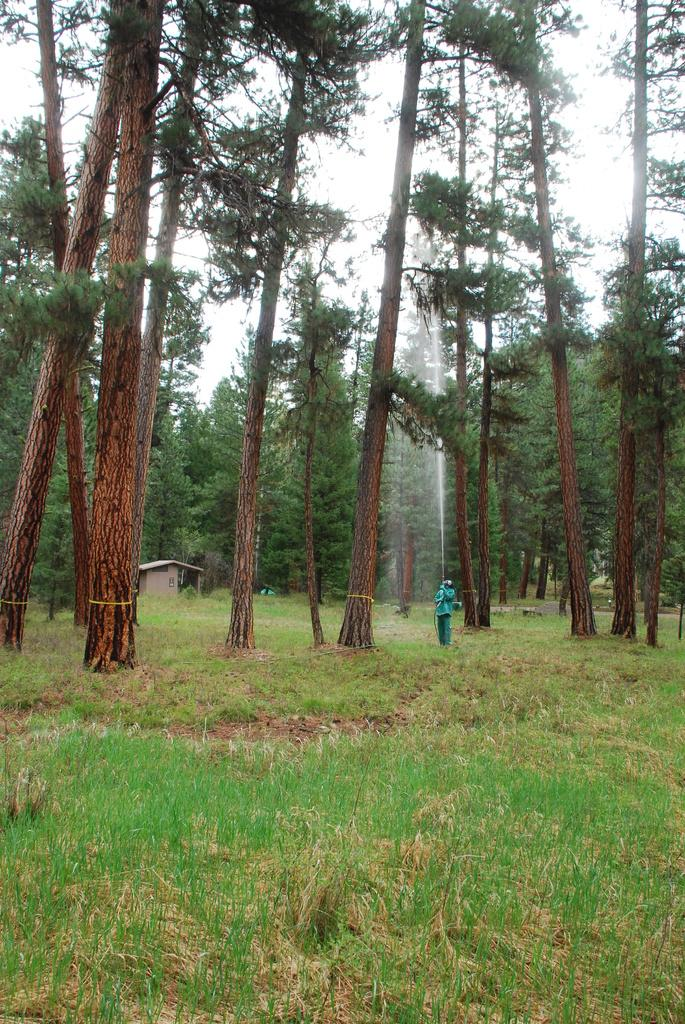What type of vegetation is present at the bottom of the image? There is grass on the ground at the bottom of the image. What can be seen in the distance in the image? There are trees, a person watering something, a house, and other objects in the background of the image. What is visible in the sky in the image? The sky is visible in the background of the image. What type of soup is being served in the image? There is no soup present in the image. Is the person in the image taking a bath? There is no indication of a bath or any bathing activity in the image. 